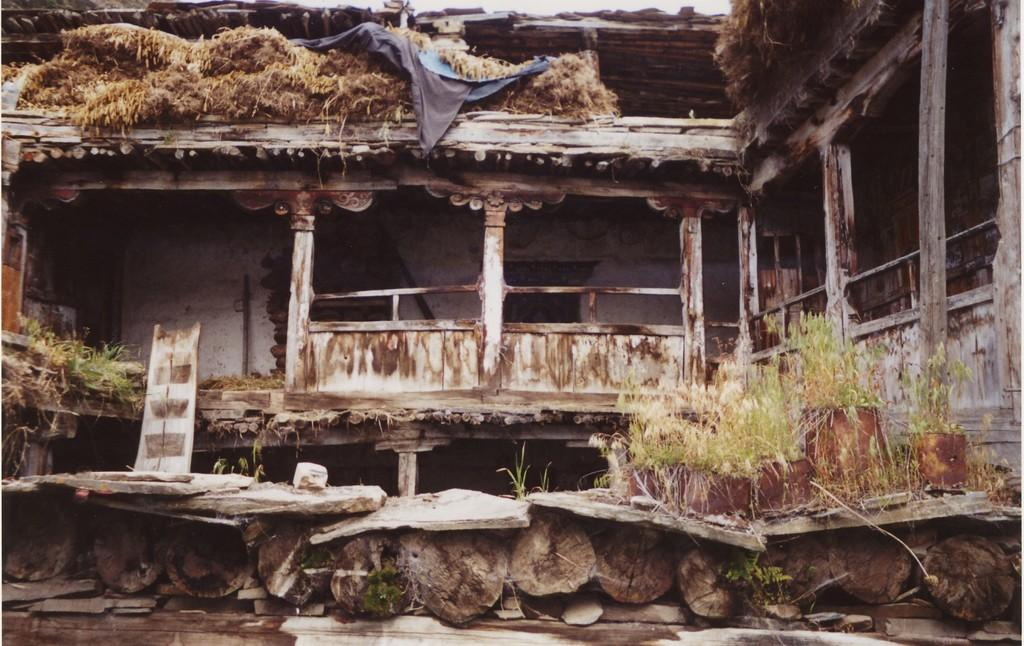What type of building is in the image? There is a wooden building in the image. What material are the logs made of? The logs are made of wood. What separates the interior and exterior spaces in the image? There are walls in the image. What type of vegetation is present in the image? There is grass in the image. What is the distance between the wooden building and the road in the image? There is no road present in the image, so it is not possible to determine the distance between the wooden building and a road. 